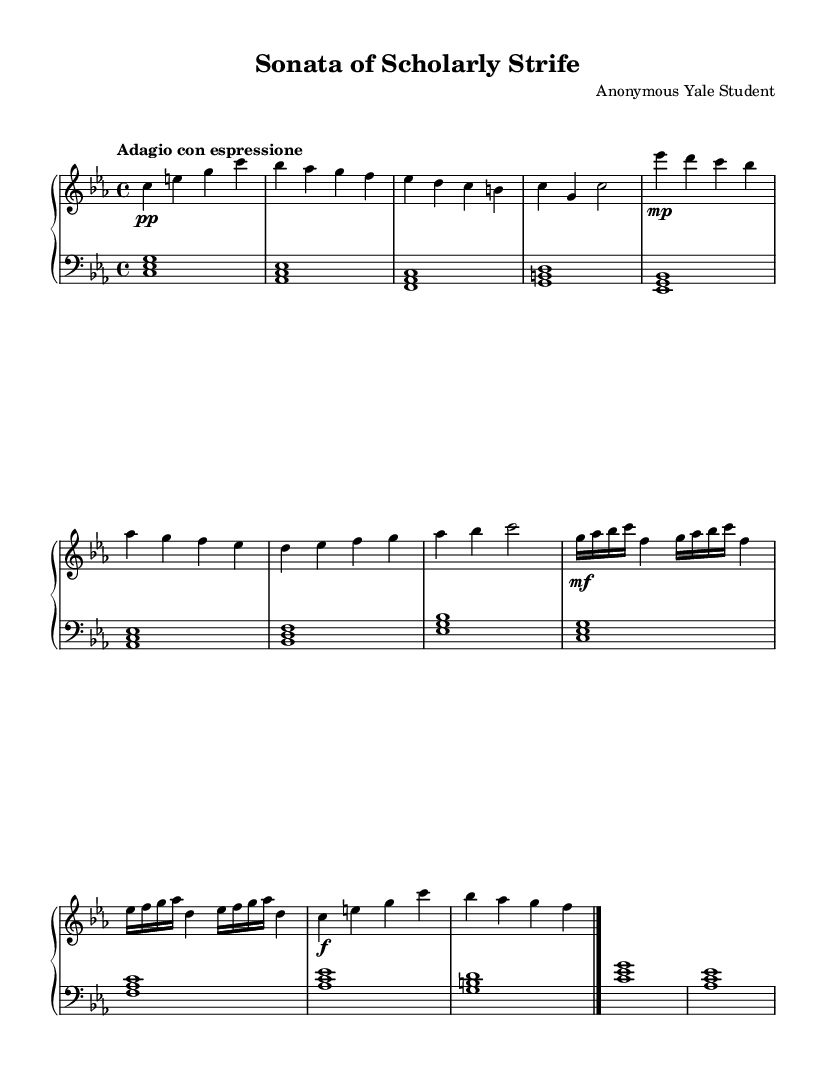What is the key signature of this music? The key signature indicates that the piece is in C minor, which has three flats (B♭, E♭, and A♭). This is evident from the key signature symbol at the beginning of the staff.
Answer: C minor What is the time signature of this music? The time signature is 4/4, which means there are four beats in a measure and a quarter note receives one beat. This can be found at the beginning of the sheet music.
Answer: 4/4 What is the tempo marking of this music? The tempo marking "Adagio con espressione" suggests a slow tempo with expressive playing. This is indicated near the beginning of the piece, guiding the performer on how to play.
Answer: Adagio con espressione How many measures are in the main theme? The main theme consists of 4 measures, which can be counted by identifying the line breaks in the upper staff where the main theme is notated.
Answer: 4 What is the dynamic marking for the development motif? The dynamic marking for the development motif is mezzo-forte, as indicated by "mf" in the upper staff. This instructs the performer to play moderately loud.
Answer: mf Does the secondary theme modulate to a different key? No, the secondary theme stays in C minor, as indicated by the lack of any sharps or flats that would suggest a modulation to a different key. It maintains the original tonality throughout.
Answer: No What emotion does the title imply about the piece? The title "Sonata of Scholarly Strife" implies a tension between ambition and mental pressure, suggesting an emotional struggle that resonates with the themes in this romantic music. This reflects the overall melancholic nature of the sonata.
Answer: Melancholic 